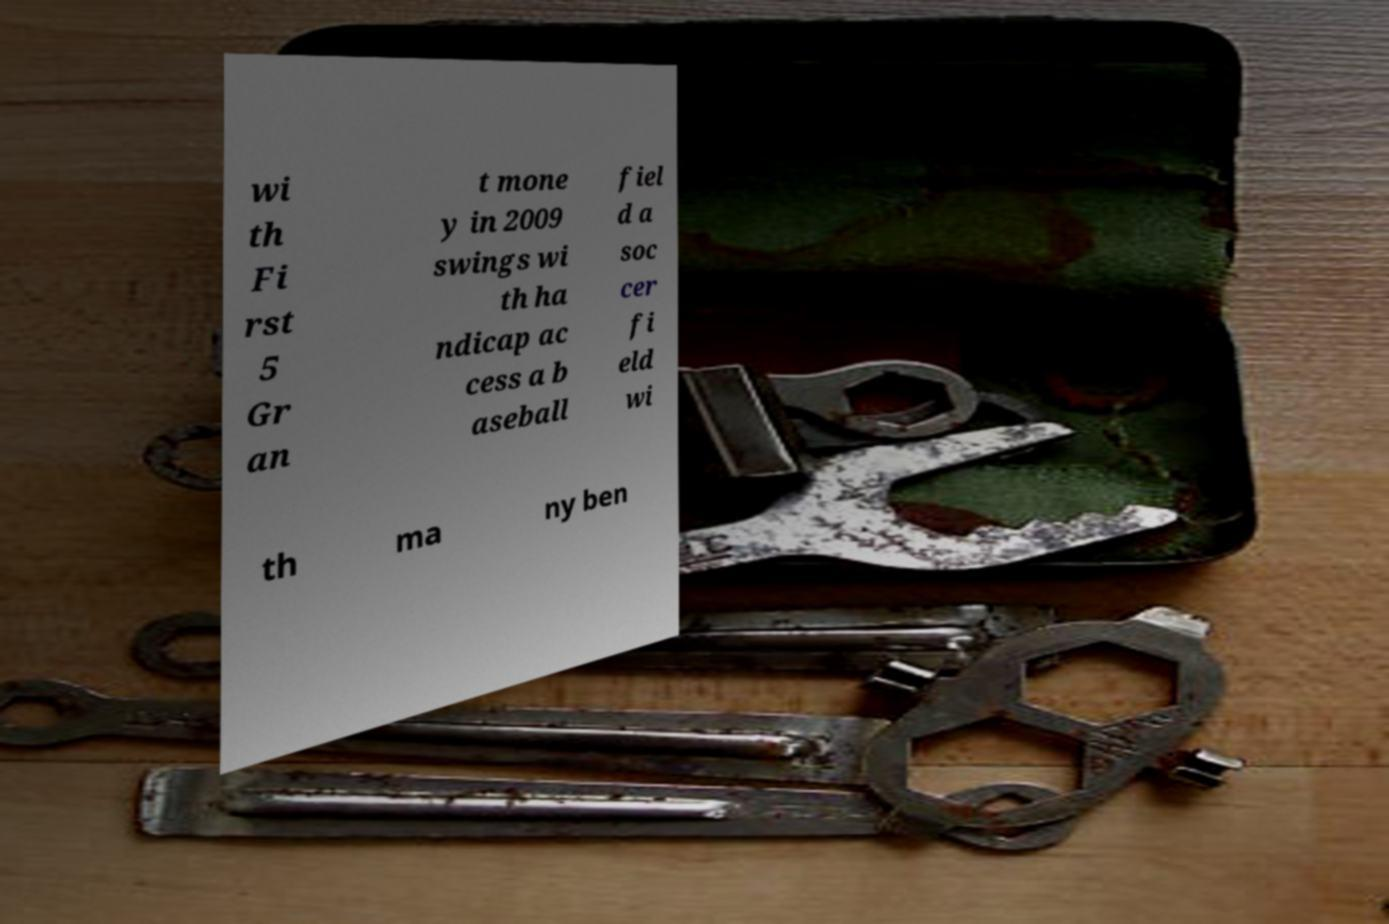Please identify and transcribe the text found in this image. wi th Fi rst 5 Gr an t mone y in 2009 swings wi th ha ndicap ac cess a b aseball fiel d a soc cer fi eld wi th ma ny ben 